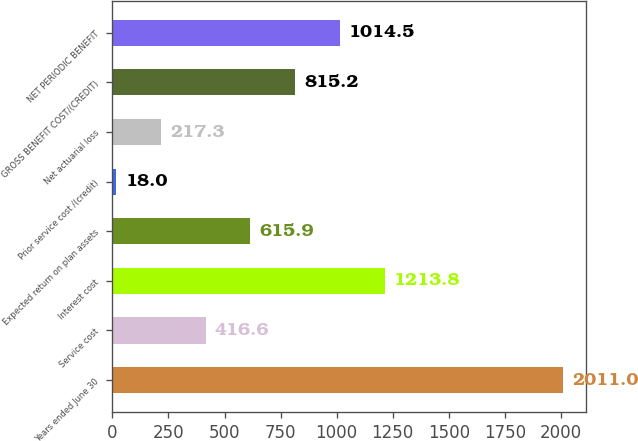Convert chart. <chart><loc_0><loc_0><loc_500><loc_500><bar_chart><fcel>Years ended June 30<fcel>Service cost<fcel>Interest cost<fcel>Expected return on plan assets<fcel>Prior service cost /(credit)<fcel>Net actuarial loss<fcel>GROSS BENEFIT COST/(CREDIT)<fcel>NET PERIODIC BENEFIT<nl><fcel>2011<fcel>416.6<fcel>1213.8<fcel>615.9<fcel>18<fcel>217.3<fcel>815.2<fcel>1014.5<nl></chart> 